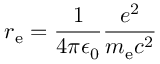<formula> <loc_0><loc_0><loc_500><loc_500>r _ { e } = { \frac { 1 } { 4 \pi \epsilon _ { 0 } } } { \frac { e ^ { 2 } } { m _ { e } c ^ { 2 } } }</formula> 